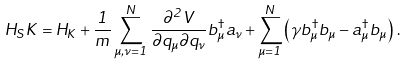Convert formula to latex. <formula><loc_0><loc_0><loc_500><loc_500>H _ { S } K = H _ { K } + \frac { 1 } { m } \sum _ { \mu , \nu = 1 } ^ { N } \frac { \partial ^ { 2 } V } { \partial q _ { \mu } \partial q _ { \nu } } b _ { \mu } ^ { \dag } a _ { \nu } + \sum _ { \mu = 1 } ^ { N } \left ( \gamma b _ { \mu } ^ { \dag } b _ { \mu } - a _ { \mu } ^ { \dag } b _ { \mu } \right ) \, .</formula> 